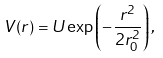<formula> <loc_0><loc_0><loc_500><loc_500>V ( r ) = U \exp \left ( - \frac { r ^ { 2 } } { 2 r _ { 0 } ^ { 2 } } \right ) ,</formula> 